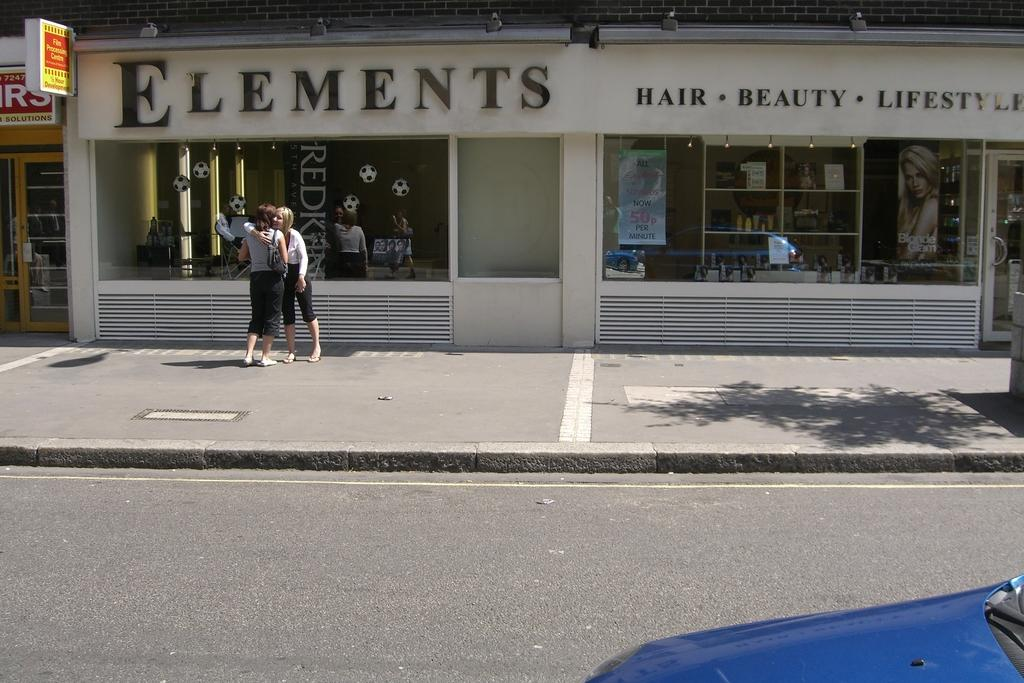<image>
Present a compact description of the photo's key features. Two women stand in front of Elements hair, beauty, and lifestyle salon 